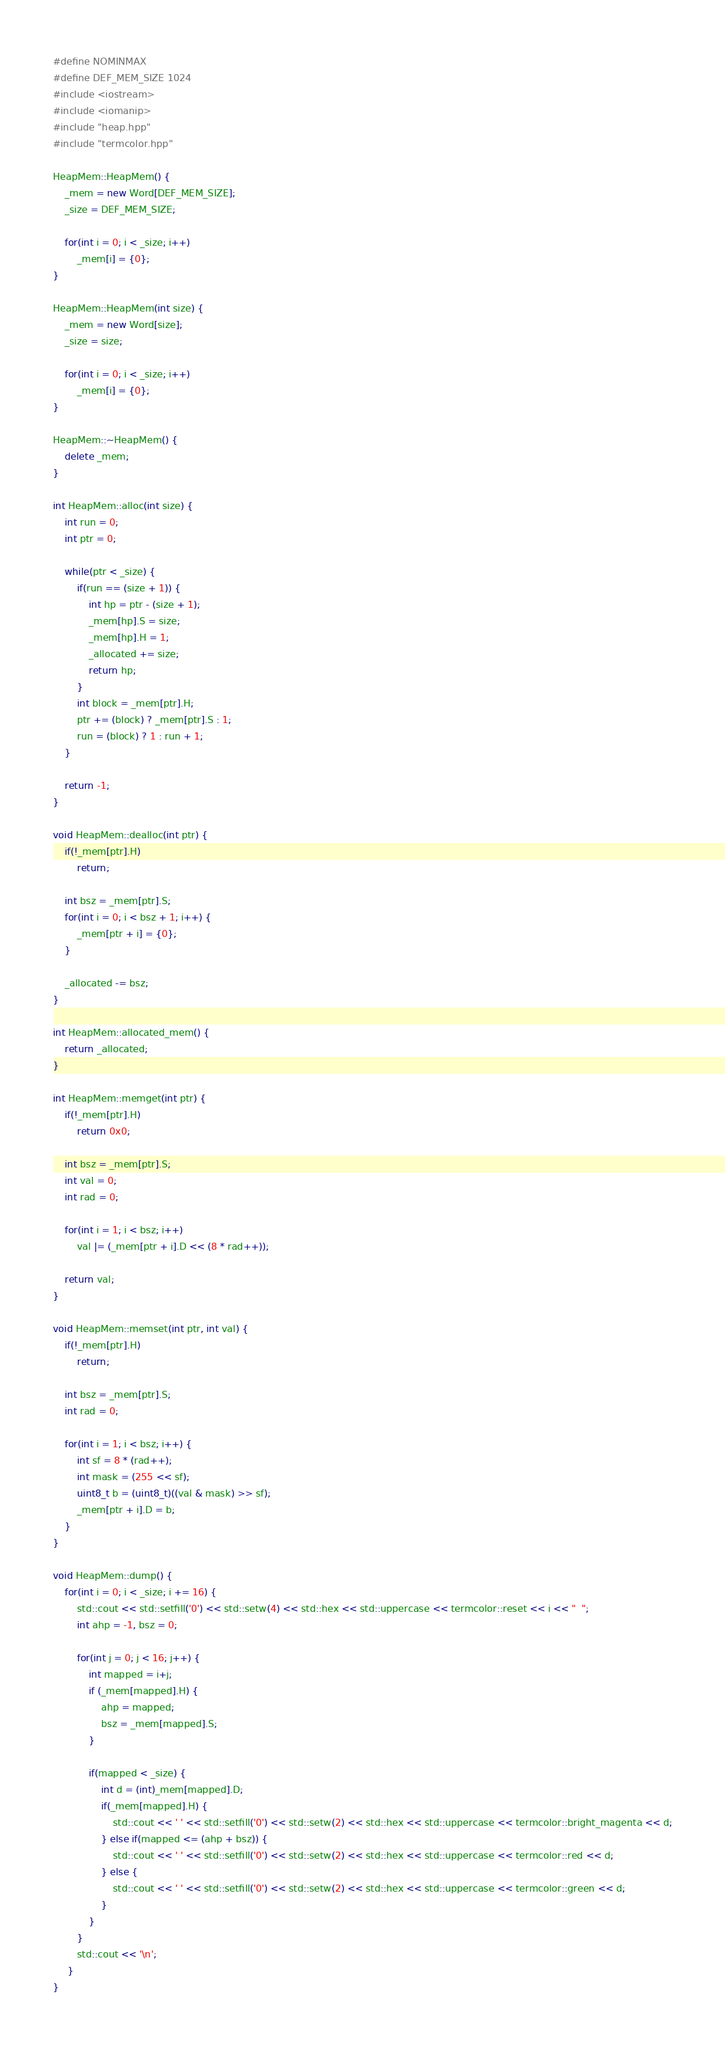<code> <loc_0><loc_0><loc_500><loc_500><_C++_>#define NOMINMAX
#define DEF_MEM_SIZE 1024
#include <iostream>
#include <iomanip>
#include "heap.hpp"
#include "termcolor.hpp"

HeapMem::HeapMem() {
    _mem = new Word[DEF_MEM_SIZE];
    _size = DEF_MEM_SIZE; 

    for(int i = 0; i < _size; i++)
        _mem[i] = {0}; 
}

HeapMem::HeapMem(int size) {
    _mem = new Word[size]; 
    _size = size;

    for(int i = 0; i < _size; i++) 
        _mem[i] = {0};  
}

HeapMem::~HeapMem() {
    delete _mem; 
} 

int HeapMem::alloc(int size) {
    int run = 0;
    int ptr = 0;  

    while(ptr < _size) {
        if(run == (size + 1)) {
            int hp = ptr - (size + 1); 
            _mem[hp].S = size;
            _mem[hp].H = 1; 
            _allocated += size; 
            return hp; 
        } 
        int block = _mem[ptr].H; 
        ptr += (block) ? _mem[ptr].S : 1; 
        run = (block) ? 1 : run + 1;  
    }

    return -1;
}

void HeapMem::dealloc(int ptr) {
    if(!_mem[ptr].H)
        return; 

    int bsz = _mem[ptr].S;  
    for(int i = 0; i < bsz + 1; i++) {
        _mem[ptr + i] = {0}; 
    }

    _allocated -= bsz; 
}

int HeapMem::allocated_mem() {
    return _allocated; 
}

int HeapMem::memget(int ptr) {
    if(!_mem[ptr].H)
        return 0x0; 

    int bsz = _mem[ptr].S;
    int val = 0;
    int rad = 0;

    for(int i = 1; i < bsz; i++) 
        val |= (_mem[ptr + i].D << (8 * rad++)); 

    return val; 
}

void HeapMem::memset(int ptr, int val) {
    if(!_mem[ptr].H)
        return; 

    int bsz = _mem[ptr].S;
    int rad = 0; 

    for(int i = 1; i < bsz; i++) {
        int sf = 8 * (rad++);
        int mask = (255 << sf); 
        uint8_t b = (uint8_t)((val & mask) >> sf); 
        _mem[ptr + i].D = b;  
    }
}

void HeapMem::dump() {
    for(int i = 0; i < _size; i += 16) {
        std::cout << std::setfill('0') << std::setw(4) << std::hex << std::uppercase << termcolor::reset << i << "  ";
        int ahp = -1, bsz = 0; 

        for(int j = 0; j < 16; j++) {
            int mapped = i+j; 
            if (_mem[mapped].H) {
                ahp = mapped; 
                bsz = _mem[mapped].S; 
            }

            if(mapped < _size) {
                int d = (int)_mem[mapped].D; 
                if(_mem[mapped].H) {
                    std::cout << ' ' << std::setfill('0') << std::setw(2) << std::hex << std::uppercase << termcolor::bright_magenta << d;
                } else if(mapped <= (ahp + bsz)) {
                    std::cout << ' ' << std::setfill('0') << std::setw(2) << std::hex << std::uppercase << termcolor::red << d;
                } else {
                    std::cout << ' ' << std::setfill('0') << std::setw(2) << std::hex << std::uppercase << termcolor::green << d;
                }
            }
        }
        std::cout << '\n'; 
     }
}</code> 